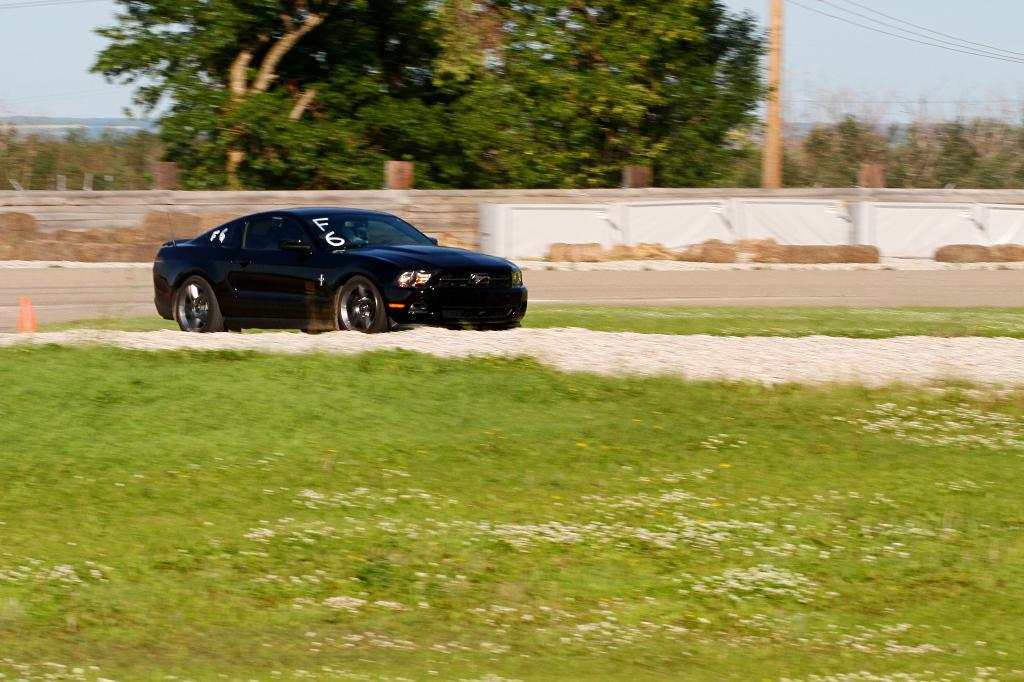Where was the image taken? The image was clicked outside. What type of ground can be seen at the bottom of the image? There is grass at the bottom of the image. What is the main object in the middle of the image? There is a car in the middle of the image. What color is the car? The car is black. What can be seen at the top of the image? There are trees and the sky visible at the top of the image. What type of shade does the car provide in the image? The car does not provide any shade in the image, as it is a black car and not a canopy or umbrella. 